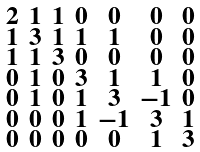Convert formula to latex. <formula><loc_0><loc_0><loc_500><loc_500>\begin{smallmatrix} 2 & 1 & 1 & 0 & 0 & 0 & 0 \\ 1 & 3 & 1 & 1 & 1 & 0 & 0 \\ 1 & 1 & 3 & 0 & 0 & 0 & 0 \\ 0 & 1 & 0 & 3 & 1 & 1 & 0 \\ 0 & 1 & 0 & 1 & 3 & - 1 & 0 \\ 0 & 0 & 0 & 1 & - 1 & 3 & 1 \\ 0 & 0 & 0 & 0 & 0 & 1 & 3 \end{smallmatrix}</formula> 